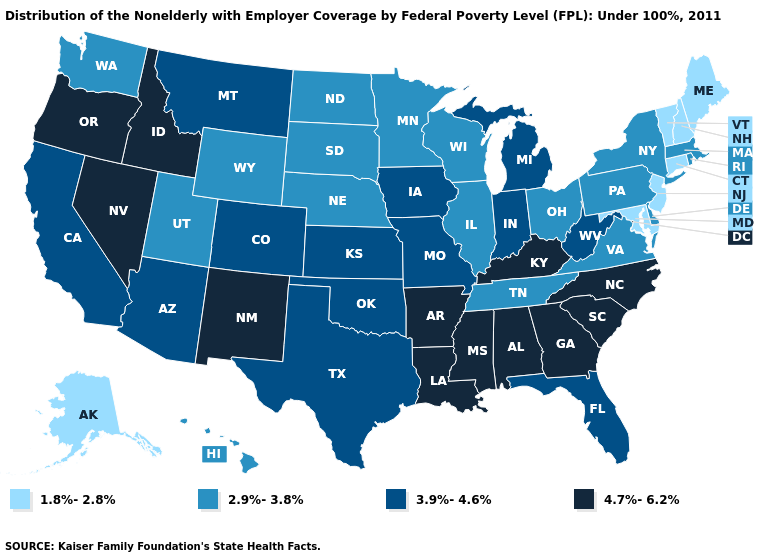Among the states that border Missouri , does Kentucky have the highest value?
Answer briefly. Yes. What is the highest value in the USA?
Write a very short answer. 4.7%-6.2%. What is the value of Minnesota?
Quick response, please. 2.9%-3.8%. Does New Hampshire have the lowest value in the USA?
Keep it brief. Yes. What is the value of Wisconsin?
Write a very short answer. 2.9%-3.8%. Which states have the lowest value in the USA?
Quick response, please. Alaska, Connecticut, Maine, Maryland, New Hampshire, New Jersey, Vermont. What is the lowest value in the USA?
Be succinct. 1.8%-2.8%. What is the value of Arkansas?
Short answer required. 4.7%-6.2%. Does Pennsylvania have a lower value than Missouri?
Be succinct. Yes. What is the value of Iowa?
Give a very brief answer. 3.9%-4.6%. What is the highest value in states that border New Hampshire?
Answer briefly. 2.9%-3.8%. What is the value of New Hampshire?
Quick response, please. 1.8%-2.8%. Which states have the lowest value in the MidWest?
Concise answer only. Illinois, Minnesota, Nebraska, North Dakota, Ohio, South Dakota, Wisconsin. Which states have the lowest value in the Northeast?
Concise answer only. Connecticut, Maine, New Hampshire, New Jersey, Vermont. Name the states that have a value in the range 3.9%-4.6%?
Answer briefly. Arizona, California, Colorado, Florida, Indiana, Iowa, Kansas, Michigan, Missouri, Montana, Oklahoma, Texas, West Virginia. 